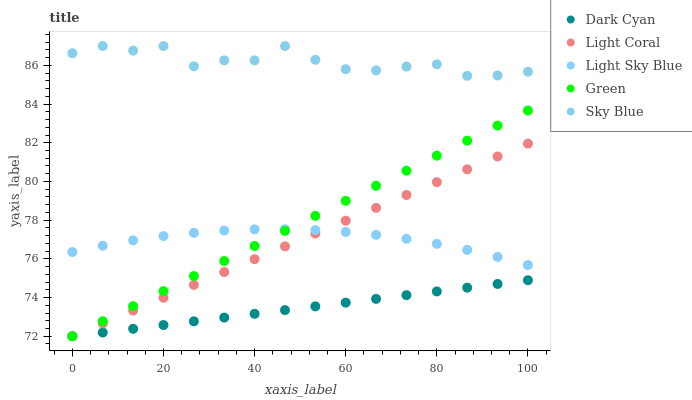Does Dark Cyan have the minimum area under the curve?
Answer yes or no. Yes. Does Sky Blue have the maximum area under the curve?
Answer yes or no. Yes. Does Light Coral have the minimum area under the curve?
Answer yes or no. No. Does Light Coral have the maximum area under the curve?
Answer yes or no. No. Is Dark Cyan the smoothest?
Answer yes or no. Yes. Is Sky Blue the roughest?
Answer yes or no. Yes. Is Light Coral the smoothest?
Answer yes or no. No. Is Light Coral the roughest?
Answer yes or no. No. Does Dark Cyan have the lowest value?
Answer yes or no. Yes. Does Light Sky Blue have the lowest value?
Answer yes or no. No. Does Sky Blue have the highest value?
Answer yes or no. Yes. Does Light Coral have the highest value?
Answer yes or no. No. Is Dark Cyan less than Light Sky Blue?
Answer yes or no. Yes. Is Sky Blue greater than Green?
Answer yes or no. Yes. Does Dark Cyan intersect Light Coral?
Answer yes or no. Yes. Is Dark Cyan less than Light Coral?
Answer yes or no. No. Is Dark Cyan greater than Light Coral?
Answer yes or no. No. Does Dark Cyan intersect Light Sky Blue?
Answer yes or no. No. 